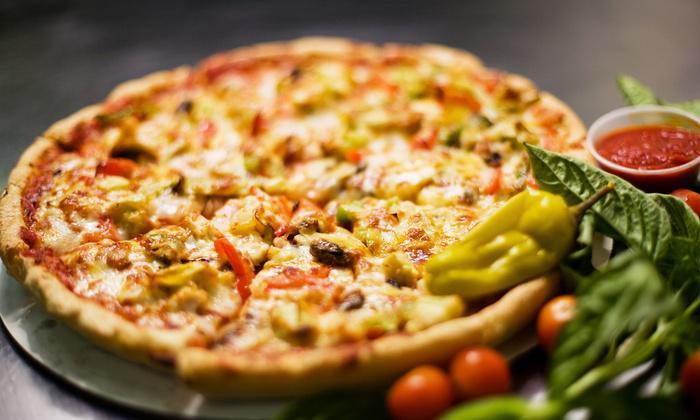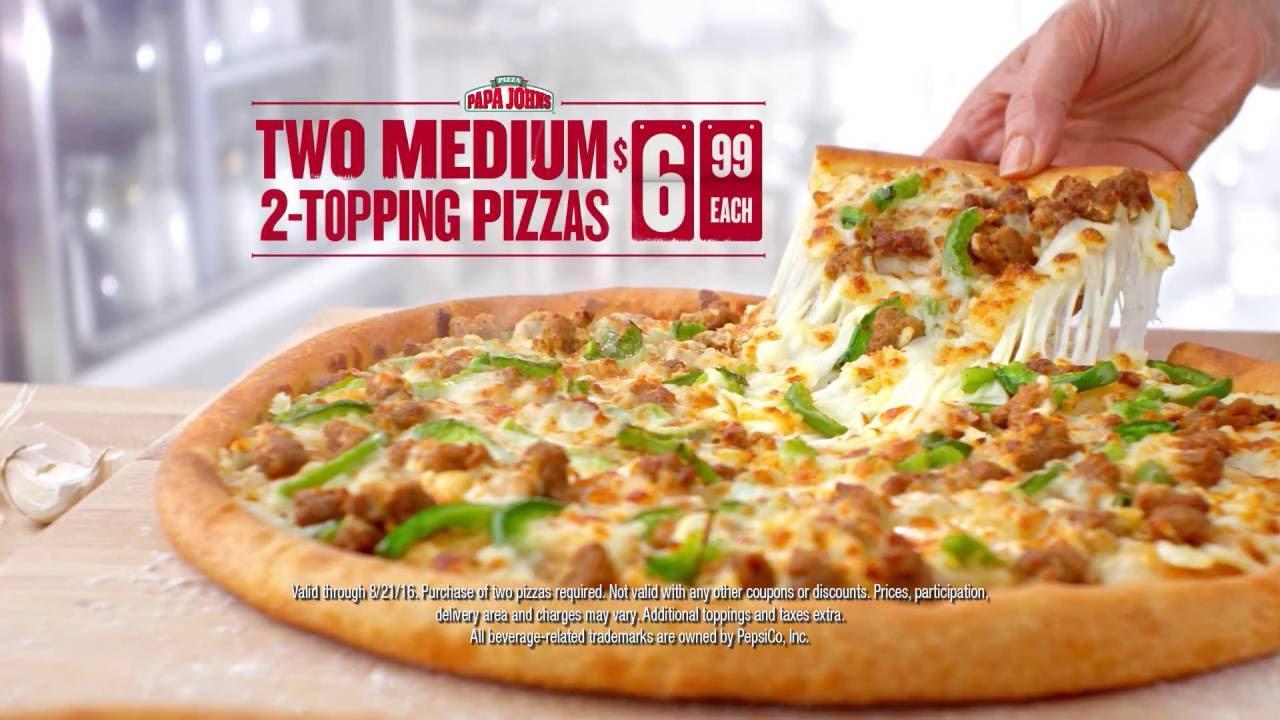The first image is the image on the left, the second image is the image on the right. Evaluate the accuracy of this statement regarding the images: "A whole pizza is on a pizza box in the right image.". Is it true? Answer yes or no. No. The first image is the image on the left, the second image is the image on the right. Given the left and right images, does the statement "One slice of pizza is being separated from the rest." hold true? Answer yes or no. Yes. 